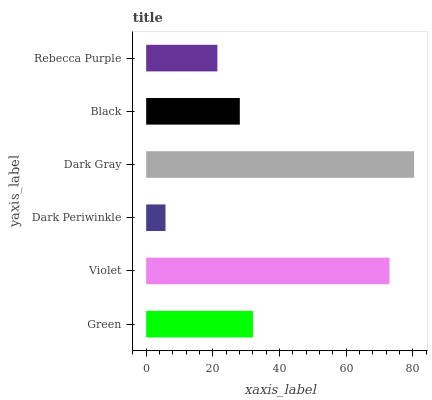Is Dark Periwinkle the minimum?
Answer yes or no. Yes. Is Dark Gray the maximum?
Answer yes or no. Yes. Is Violet the minimum?
Answer yes or no. No. Is Violet the maximum?
Answer yes or no. No. Is Violet greater than Green?
Answer yes or no. Yes. Is Green less than Violet?
Answer yes or no. Yes. Is Green greater than Violet?
Answer yes or no. No. Is Violet less than Green?
Answer yes or no. No. Is Green the high median?
Answer yes or no. Yes. Is Black the low median?
Answer yes or no. Yes. Is Black the high median?
Answer yes or no. No. Is Dark Gray the low median?
Answer yes or no. No. 